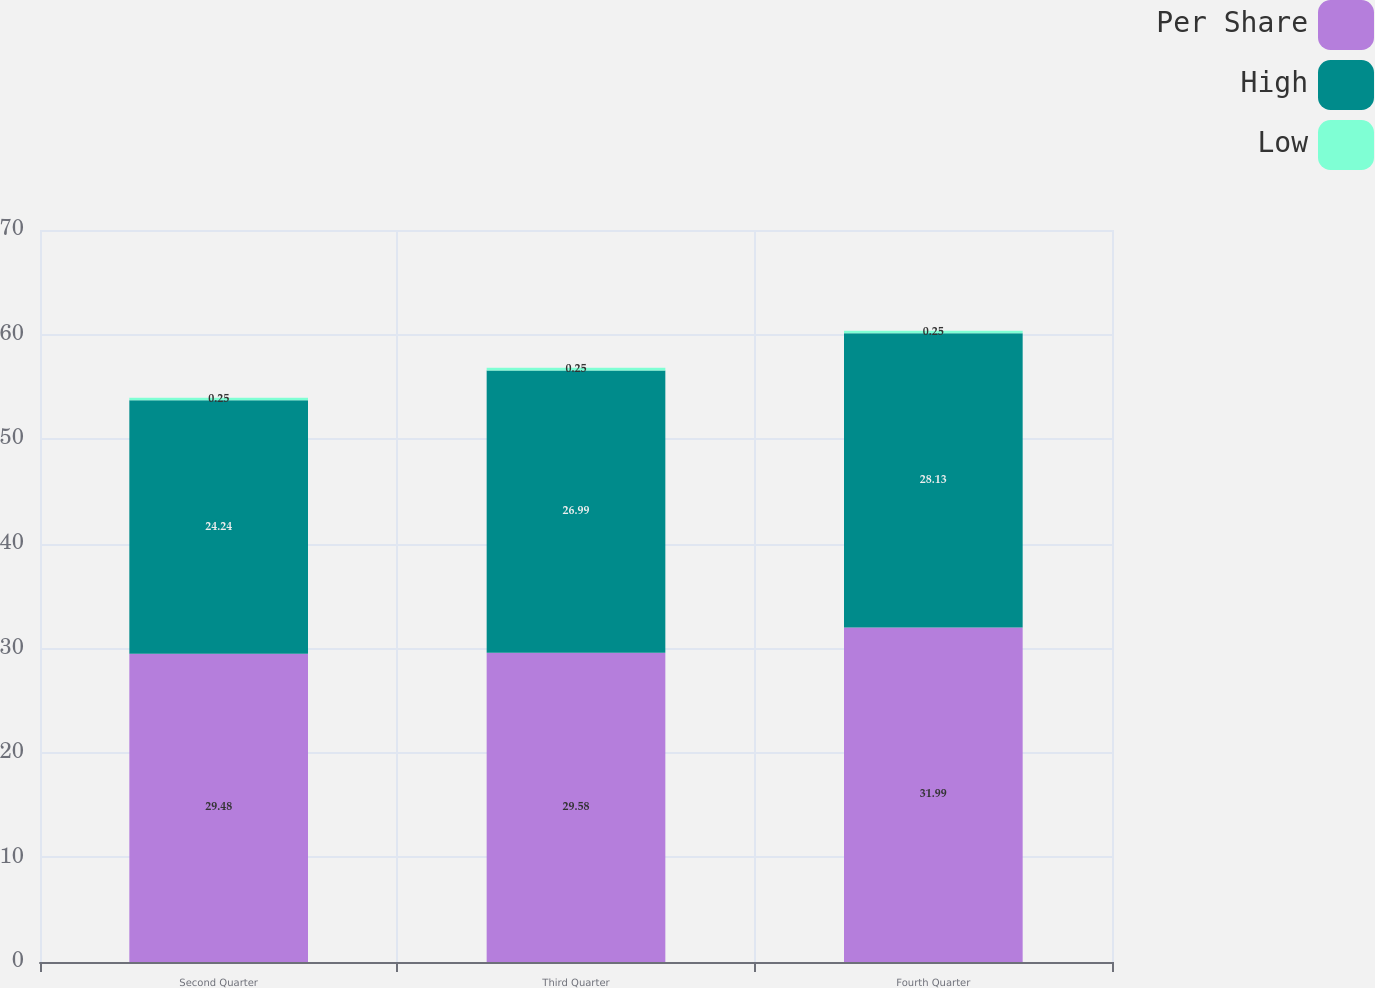<chart> <loc_0><loc_0><loc_500><loc_500><stacked_bar_chart><ecel><fcel>Second Quarter<fcel>Third Quarter<fcel>Fourth Quarter<nl><fcel>Per Share<fcel>29.48<fcel>29.58<fcel>31.99<nl><fcel>High<fcel>24.24<fcel>26.99<fcel>28.13<nl><fcel>Low<fcel>0.25<fcel>0.25<fcel>0.25<nl></chart> 